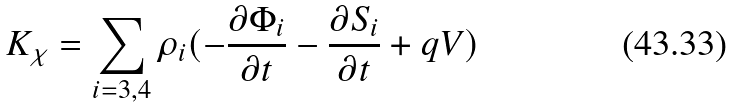<formula> <loc_0><loc_0><loc_500><loc_500>K _ { \chi } = \sum _ { i = 3 , 4 } \rho _ { i } ( - \frac { \partial \Phi _ { i } } { \partial t } - \frac { \partial S _ { i } } { \partial t } + q V )</formula> 